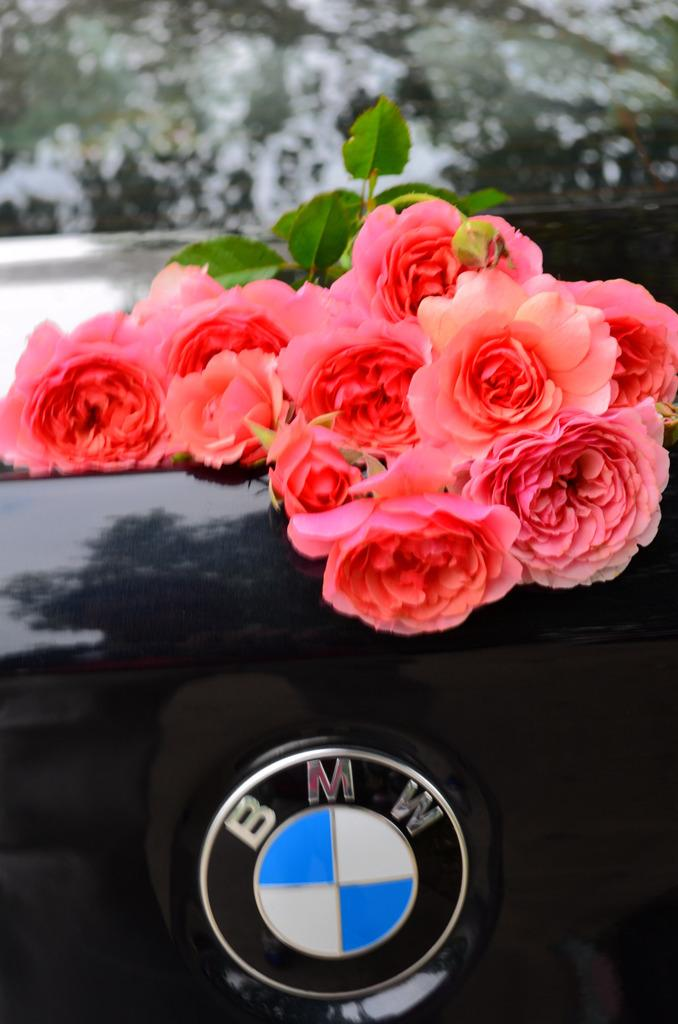What type of flowers are in the image? There are roses in the image. Where are the roses located? The roses are placed on a car. How many women are holding scissors in the image? There are no women or scissors present in the image. 